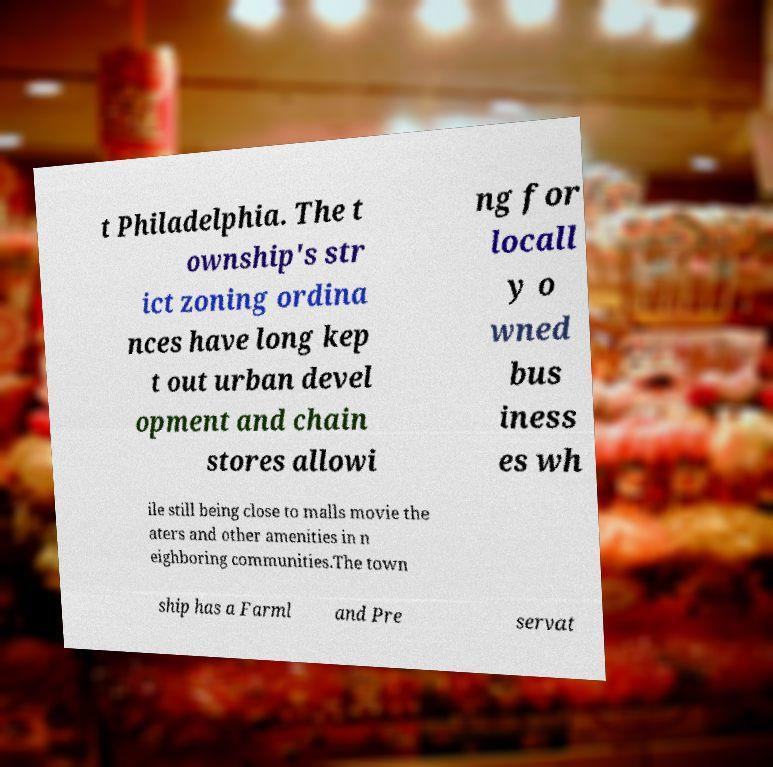I need the written content from this picture converted into text. Can you do that? t Philadelphia. The t ownship's str ict zoning ordina nces have long kep t out urban devel opment and chain stores allowi ng for locall y o wned bus iness es wh ile still being close to malls movie the aters and other amenities in n eighboring communities.The town ship has a Farml and Pre servat 